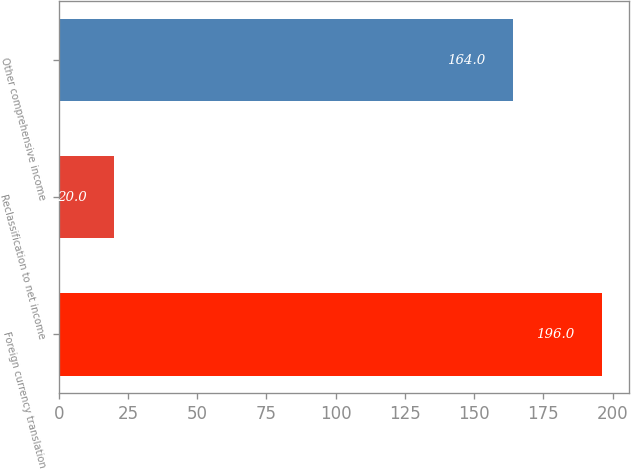Convert chart. <chart><loc_0><loc_0><loc_500><loc_500><bar_chart><fcel>Foreign currency translation<fcel>Reclassification to net income<fcel>Other comprehensive income<nl><fcel>196<fcel>20<fcel>164<nl></chart> 